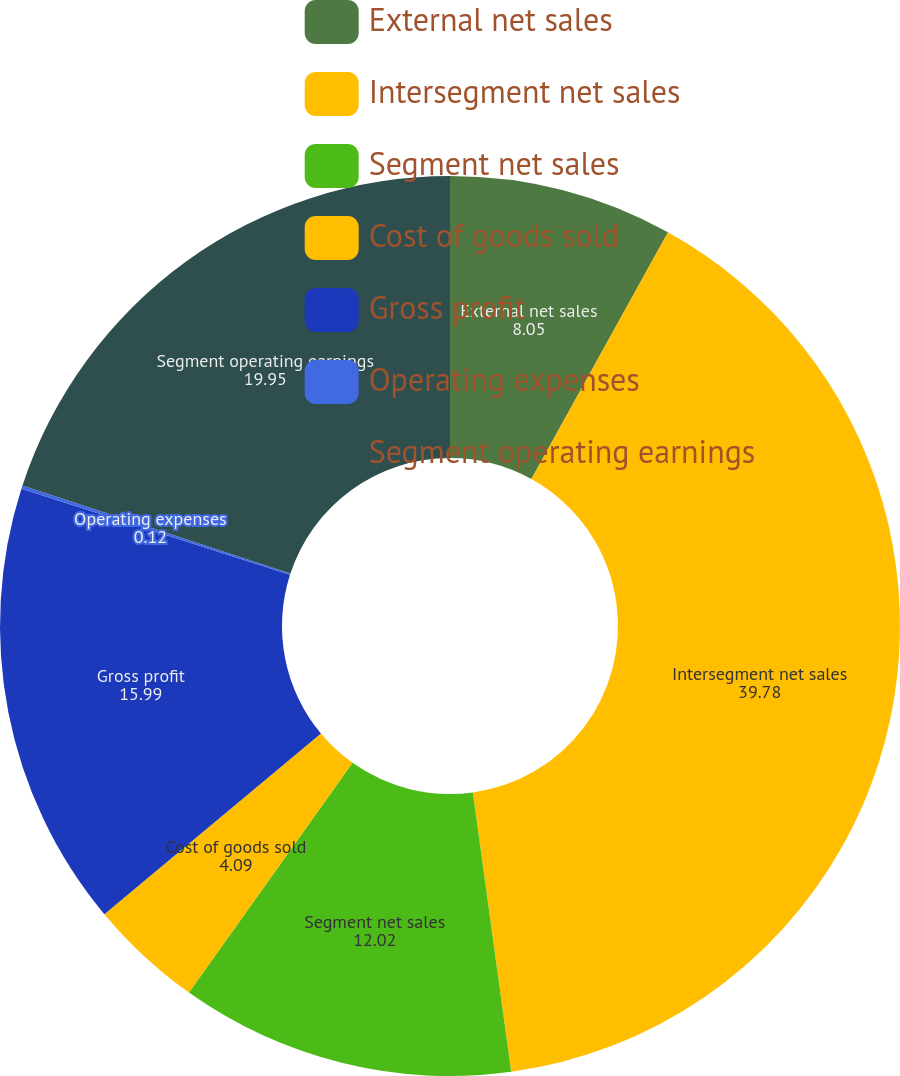Convert chart. <chart><loc_0><loc_0><loc_500><loc_500><pie_chart><fcel>External net sales<fcel>Intersegment net sales<fcel>Segment net sales<fcel>Cost of goods sold<fcel>Gross profit<fcel>Operating expenses<fcel>Segment operating earnings<nl><fcel>8.05%<fcel>39.78%<fcel>12.02%<fcel>4.09%<fcel>15.99%<fcel>0.12%<fcel>19.95%<nl></chart> 